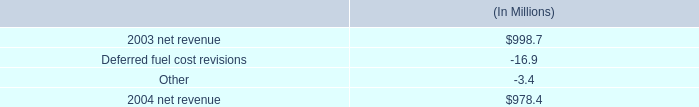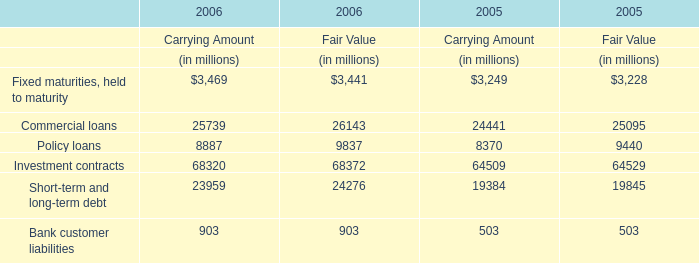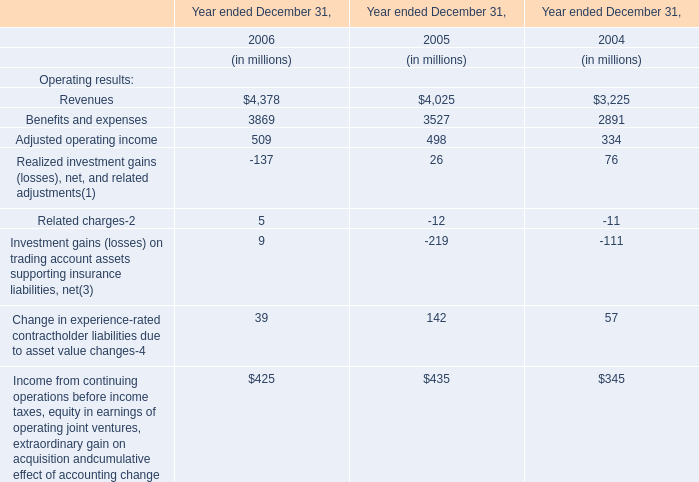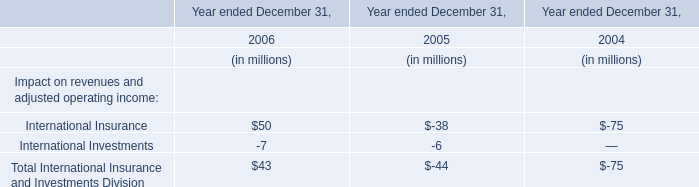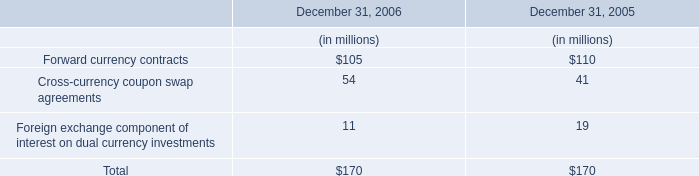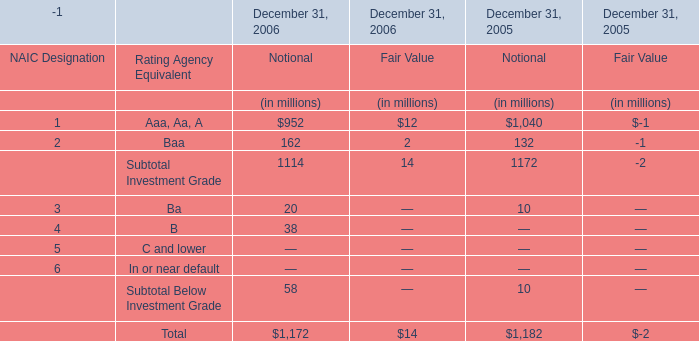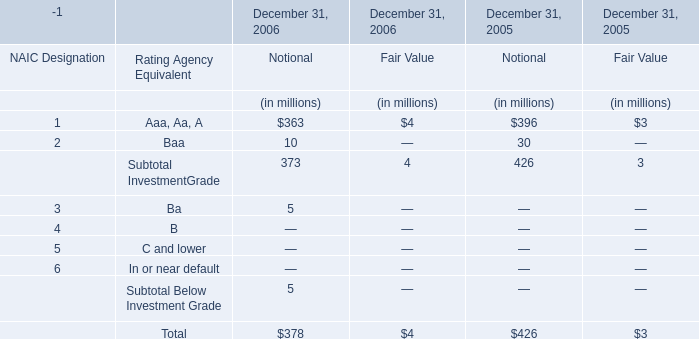What is the proportion of Aaa, Aa, A to the total in 2006 for Notional? 
Computations: (363 / 378)
Answer: 0.96032. 